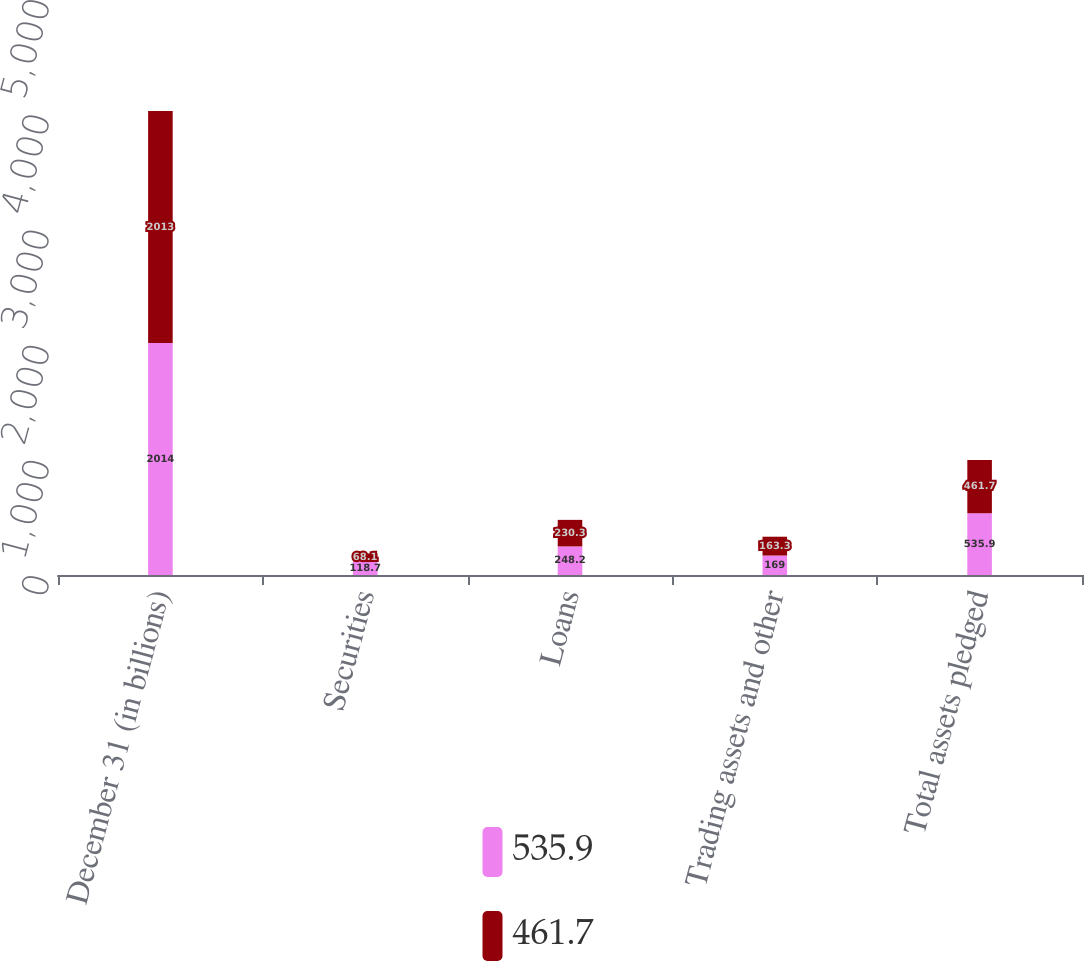<chart> <loc_0><loc_0><loc_500><loc_500><stacked_bar_chart><ecel><fcel>December 31 (in billions)<fcel>Securities<fcel>Loans<fcel>Trading assets and other<fcel>Total assets pledged<nl><fcel>535.9<fcel>2014<fcel>118.7<fcel>248.2<fcel>169<fcel>535.9<nl><fcel>461.7<fcel>2013<fcel>68.1<fcel>230.3<fcel>163.3<fcel>461.7<nl></chart> 